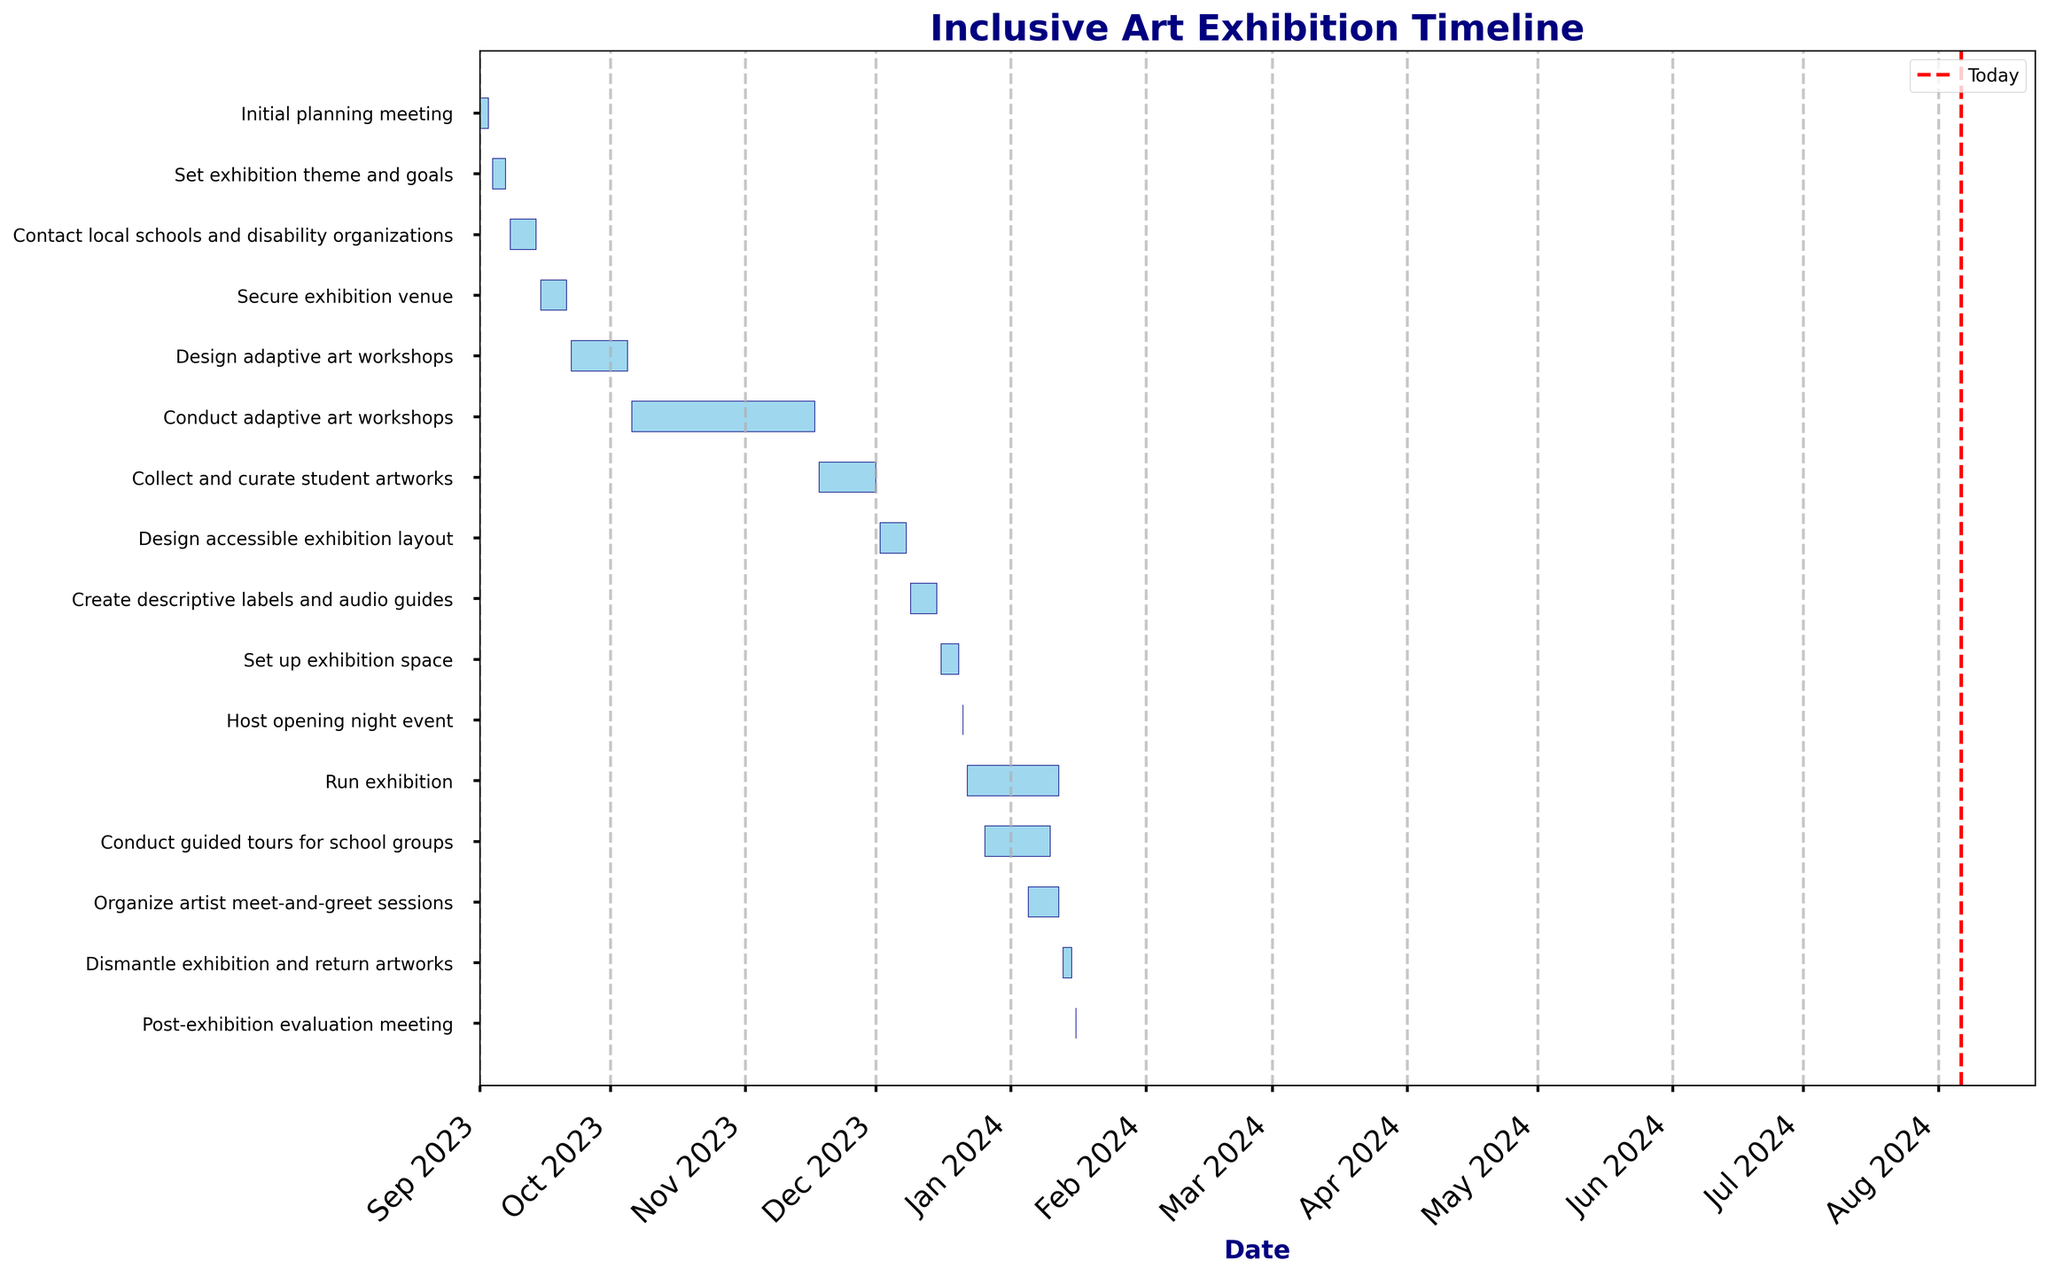"What is the title of the Gantt chart?" The title is usually found at the top of the chart. In this case, it reads 'Inclusive Art Exhibition Timeline'.
Answer: Inclusive Art Exhibition Timeline "What are the start and end dates for the 'Design adaptive art workshops' task?" The task bars visually represent the duration of each task. For 'Design adaptive art workshops', the start date is at the left end of its bar and the end date is at the right end. These dates are labeled on the x-axis.
Answer: 2023-09-22, 2023-10-05 "How long will the exhibition run?" The duration of each task can be calculated by looking at the length of its bar in relation to the x-axis dates. The 'Run exhibition' bar starts on 2023-12-22 and ends on 2024-01-12.
Answer: 22 days "Which task has the shortest duration?" By visually comparing the length of each bar, we find that the 'Host opening night event' task has the shortest bar, indicating its duration is just one day.
Answer: Host opening night event "How many tasks are planned for December 2023?" Each task's duration is represented by a bar. By looking at the x-axis for December 2023 and counting the overlapping bars, we see that there are five tasks.
Answer: 5 "What is the duration of the 'Collect and curate student artworks' task?" By comparing the bars, the 'Collect and curate student artworks' task starts on 2023-11-18 and ends on 2023-12-01. The number of days between these dates is 14.
Answer: 14 days "Do any tasks overlap in their dates?" Upon visual inspection, multiple tasks overlap. For example, 'Conduct guided tours for school groups' overlaps with 'Run exhibition' and 'Organize artist meet-and-greet sessions'.
Answer: Yes "Which task finishes first: 'Secure exhibition venue' or 'Contact local schools and disability organizations'?" Comparing the end points of the bars, 'Contact local schools and disability organizations' ends on 2023-09-14, whereas 'Secure exhibition venue' ends on 2023-09-21.
Answer: Contact local schools and disability organizations "By how many days does the 'Conduct guided tours for school groups' task overlap with the 'Run exhibition' task?" Both tasks' bars overlap from 2023-12-26 to 2024-01-10. Counting these days gives the overlap duration of 16 days.
Answer: 16 days "Which task starts immediately after 'Set exhibition theme and goals'?" Checking the end date of 'Set exhibition theme and goals' (2023-09-07) and the next task that starts (2023-09-08) is 'Contact local schools and disability organizations'.
Answer: Contact local schools and disability organizations 